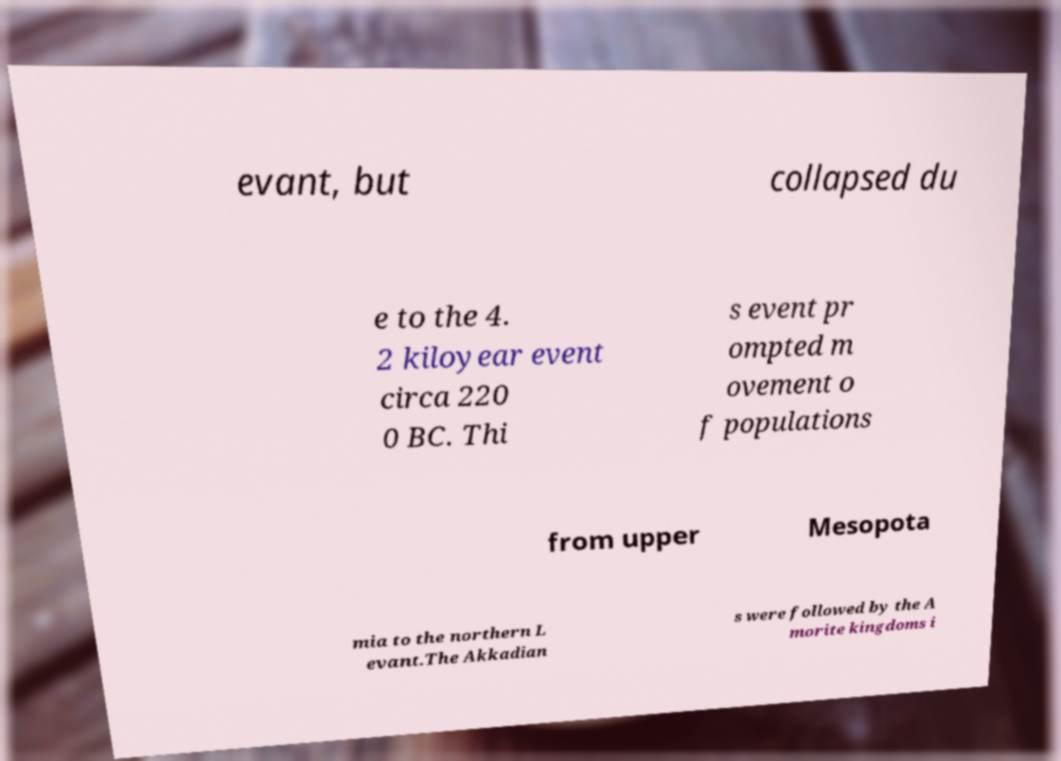Could you extract and type out the text from this image? evant, but collapsed du e to the 4. 2 kiloyear event circa 220 0 BC. Thi s event pr ompted m ovement o f populations from upper Mesopota mia to the northern L evant.The Akkadian s were followed by the A morite kingdoms i 